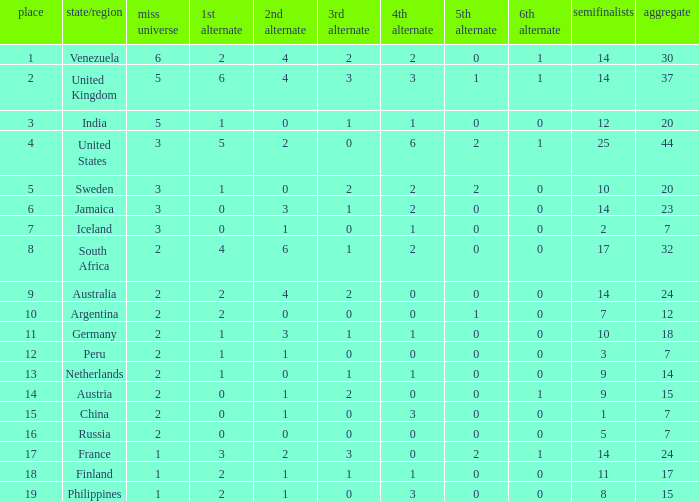Give me the full table as a dictionary. {'header': ['place', 'state/region', 'miss universe', '1st alternate', '2nd alternate', '3rd alternate', '4th alternate', '5th alternate', '6th alternate', 'semifinalists', 'aggregate'], 'rows': [['1', 'Venezuela', '6', '2', '4', '2', '2', '0', '1', '14', '30'], ['2', 'United Kingdom', '5', '6', '4', '3', '3', '1', '1', '14', '37'], ['3', 'India', '5', '1', '0', '1', '1', '0', '0', '12', '20'], ['4', 'United States', '3', '5', '2', '0', '6', '2', '1', '25', '44'], ['5', 'Sweden', '3', '1', '0', '2', '2', '2', '0', '10', '20'], ['6', 'Jamaica', '3', '0', '3', '1', '2', '0', '0', '14', '23'], ['7', 'Iceland', '3', '0', '1', '0', '1', '0', '0', '2', '7'], ['8', 'South Africa', '2', '4', '6', '1', '2', '0', '0', '17', '32'], ['9', 'Australia', '2', '2', '4', '2', '0', '0', '0', '14', '24'], ['10', 'Argentina', '2', '2', '0', '0', '0', '1', '0', '7', '12'], ['11', 'Germany', '2', '1', '3', '1', '1', '0', '0', '10', '18'], ['12', 'Peru', '2', '1', '1', '0', '0', '0', '0', '3', '7'], ['13', 'Netherlands', '2', '1', '0', '1', '1', '0', '0', '9', '14'], ['14', 'Austria', '2', '0', '1', '2', '0', '0', '1', '9', '15'], ['15', 'China', '2', '0', '1', '0', '3', '0', '0', '1', '7'], ['16', 'Russia', '2', '0', '0', '0', '0', '0', '0', '5', '7'], ['17', 'France', '1', '3', '2', '3', '0', '2', '1', '14', '24'], ['18', 'Finland', '1', '2', '1', '1', '1', '0', '0', '11', '17'], ['19', 'Philippines', '1', '2', '1', '0', '3', '0', '0', '8', '15']]} What is Iceland's total? 1.0. 